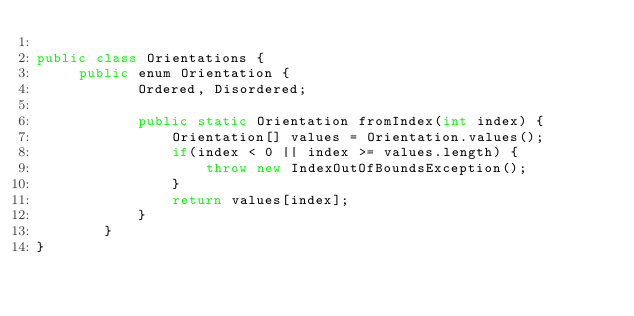<code> <loc_0><loc_0><loc_500><loc_500><_Java_>
public class Orientations {
	 public enum Orientation {
	        Ordered, Disordered;

	        public static Orientation fromIndex(int index) {
		        Orientation[] values = Orientation.values();
		        if(index < 0 || index >= values.length) {
			        throw new IndexOutOfBoundsException();
		        }
		        return values[index];
	        }
	    }
}
</code> 